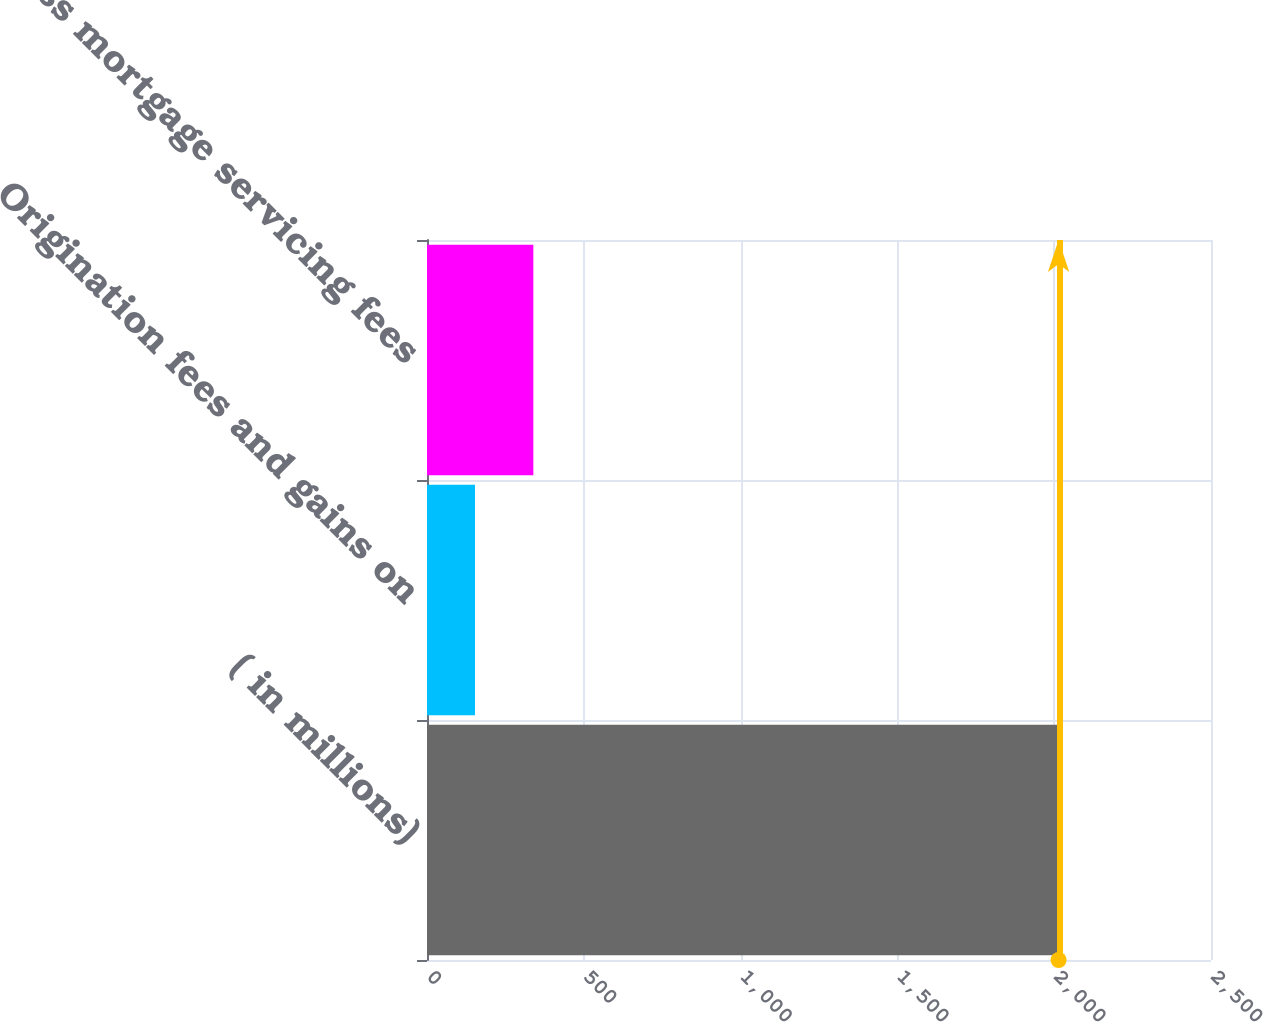Convert chart. <chart><loc_0><loc_0><loc_500><loc_500><bar_chart><fcel>( in millions)<fcel>Origination fees and gains on<fcel>Gross mortgage servicing fees<nl><fcel>2014<fcel>153<fcel>339.1<nl></chart> 